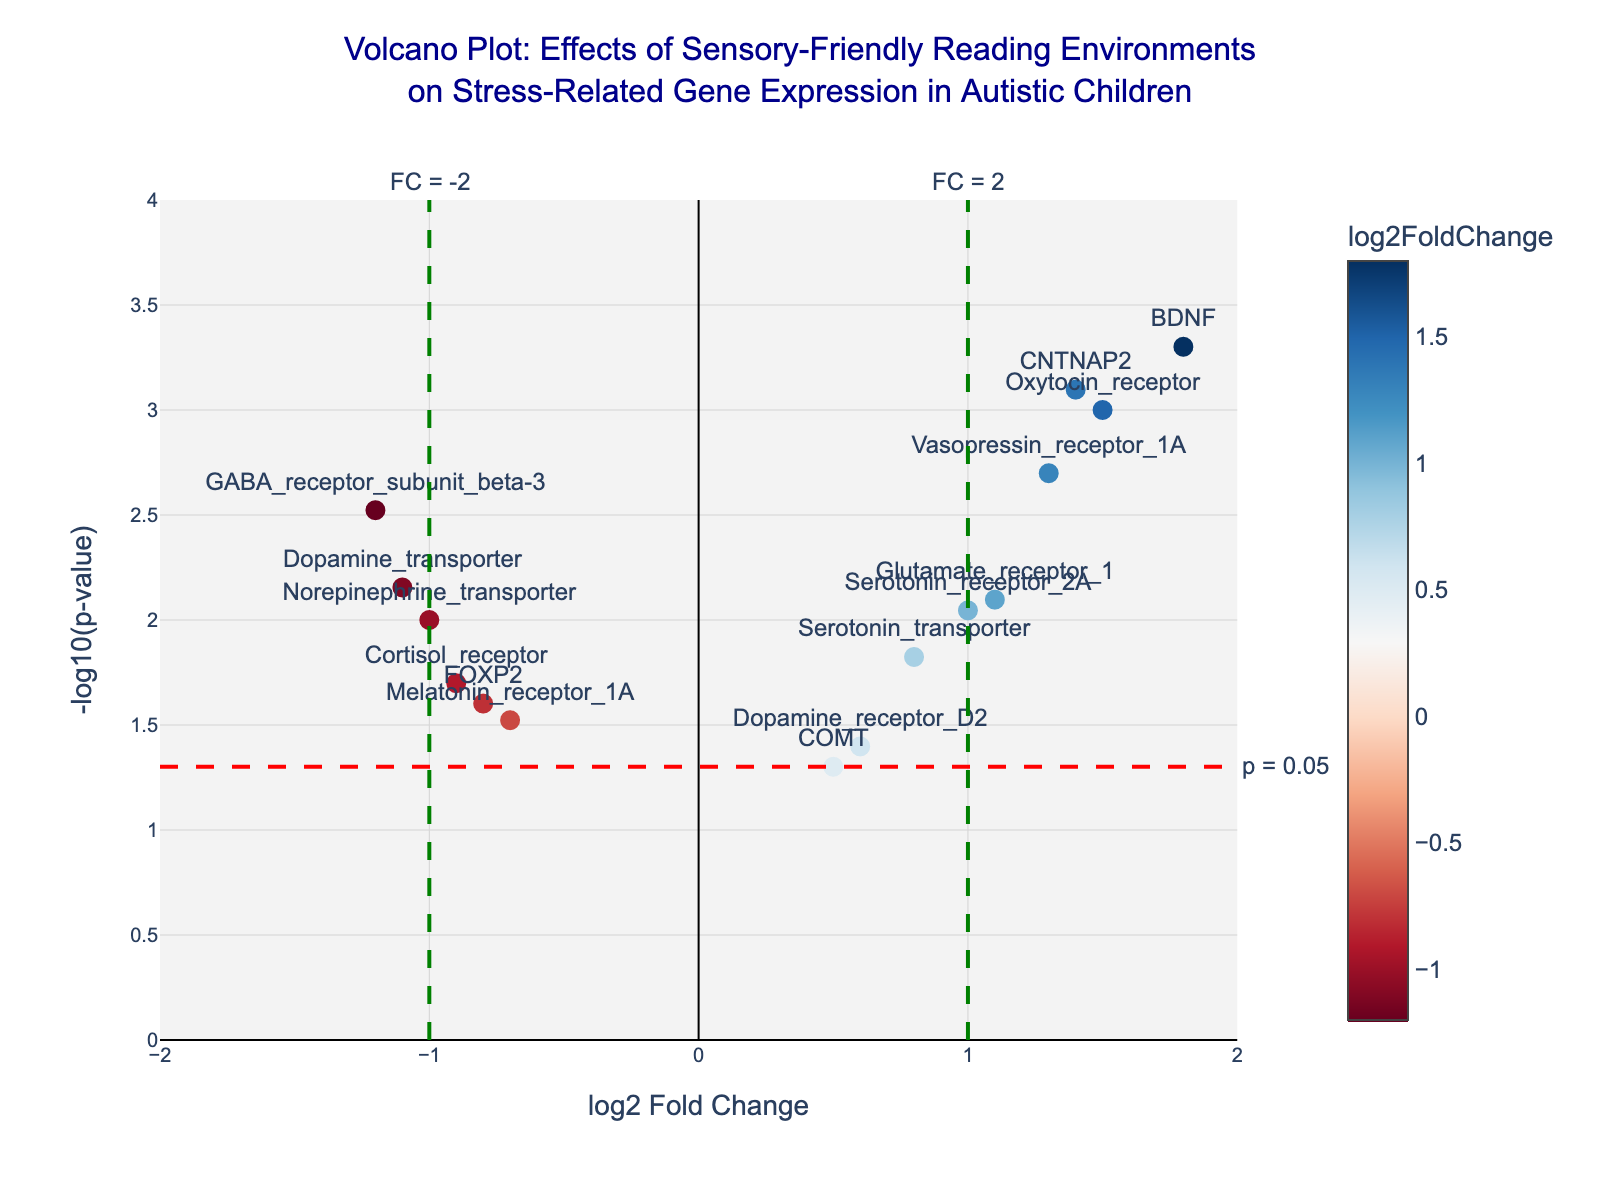Which gene has the highest log2 Fold Change? The gene with the highest log2 Fold Change is the one with the furthest positive value on the x-axis.
Answer: BDNF Which gene has the lowest p-value? The gene with the lowest p-value is the one with the highest -log10(p-value) on the y-axis.
Answer: BDNF Are there any genes with log2 Fold Change less than -1 and p-value less than 0.01? To find this, look for points to the left of x = -1 and above y = 2 on the plot.
Answer: Yes, the GABA_receptor_subunit_beta-3 and Dopamine_transporter How many genes have a log2 Fold Change greater than 1 and significant p-value (p-value < 0.05)? Count the points to the right of x = 1 and above y = 1.3, which represents -log10(0.05).
Answer: Four genes Which gene is closest to the significance threshold line at -log10(p-value) = 1.3? Identify the point closest to the dashed red line at y = 1.3.
Answer: COMT What is the log2 Fold Change and p-value of the Oxytocin_receptor gene? Locate the Oxytocin_receptor label and refer to the x and y positions of this point.
Answer: log2 Fold Change: 1.5, p-value: 0.001 Compare the expressions of Serotonin_transporter and Norepinephrine_transporter. Which one shows a higher fold change and which one is more statistically significant? Compare the x and y values for both points. Look for higher log2 Fold Change and higher -log10(p-value).
Answer: Serotonin_transporter: Higher fold change, Norepinephrine_transporter: More significant Which gene has the least significant p-value and what is its log2 Fold Change? Identify the point with the lowest -log10(p-value) and refer to its x value.
Answer: COMT, 0.5 How many genes show a decrease in expression (negative log2 Fold Change)? Count the points to the left of x = 0.
Answer: Six genes 